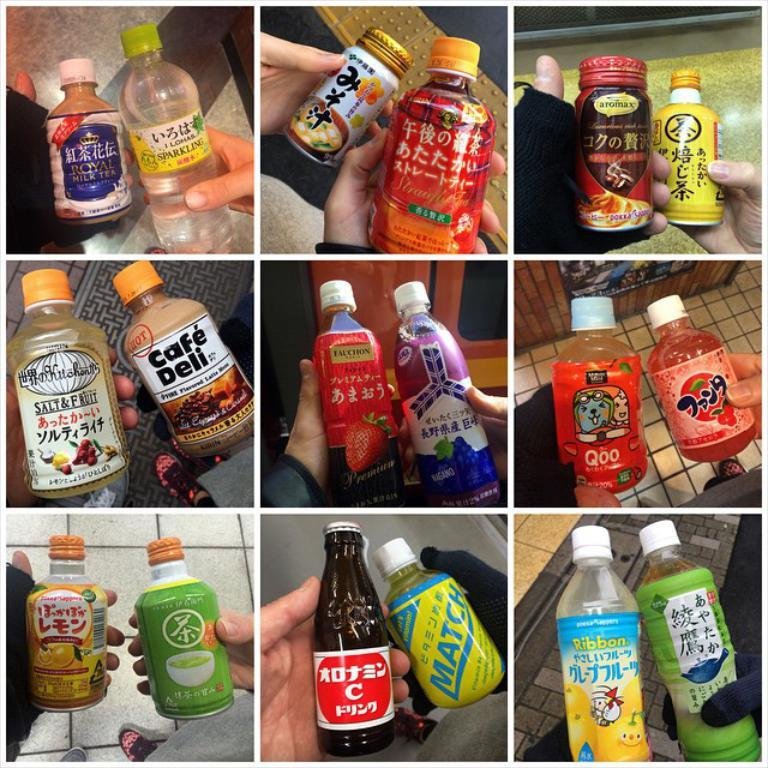Provide a one-sentence caption for the provided image. Nine separate panels each feature two beverages with labels in both English and foreign characters describing the bottle's contents. 